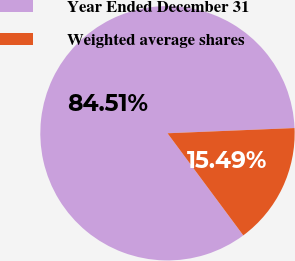Convert chart. <chart><loc_0><loc_0><loc_500><loc_500><pie_chart><fcel>Year Ended December 31<fcel>Weighted average shares<nl><fcel>84.51%<fcel>15.49%<nl></chart> 